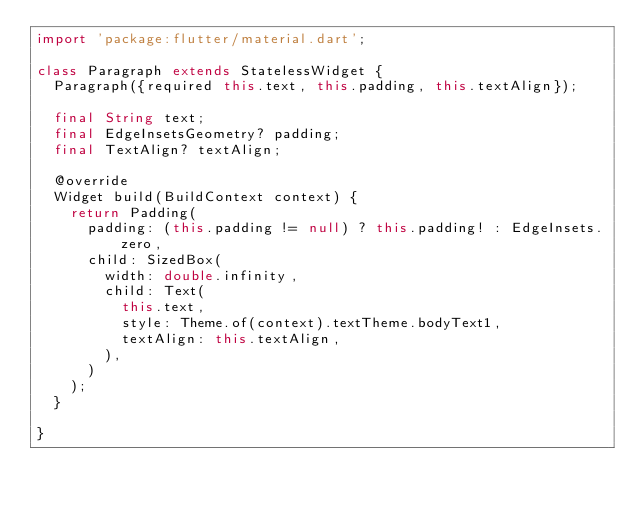Convert code to text. <code><loc_0><loc_0><loc_500><loc_500><_Dart_>import 'package:flutter/material.dart';

class Paragraph extends StatelessWidget {
  Paragraph({required this.text, this.padding, this.textAlign});

  final String text;
  final EdgeInsetsGeometry? padding;
  final TextAlign? textAlign;

  @override
  Widget build(BuildContext context) {
    return Padding(
      padding: (this.padding != null) ? this.padding! : EdgeInsets.zero,
      child: SizedBox(
        width: double.infinity,
        child: Text(
          this.text,
          style: Theme.of(context).textTheme.bodyText1,
          textAlign: this.textAlign,
        ),
      )
    );
  }

}</code> 